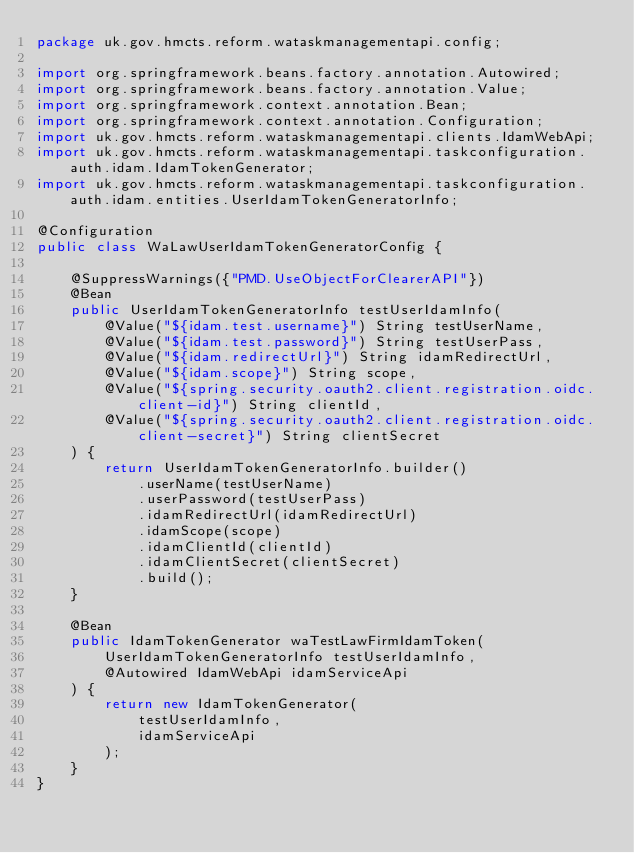Convert code to text. <code><loc_0><loc_0><loc_500><loc_500><_Java_>package uk.gov.hmcts.reform.wataskmanagementapi.config;

import org.springframework.beans.factory.annotation.Autowired;
import org.springframework.beans.factory.annotation.Value;
import org.springframework.context.annotation.Bean;
import org.springframework.context.annotation.Configuration;
import uk.gov.hmcts.reform.wataskmanagementapi.clients.IdamWebApi;
import uk.gov.hmcts.reform.wataskmanagementapi.taskconfiguration.auth.idam.IdamTokenGenerator;
import uk.gov.hmcts.reform.wataskmanagementapi.taskconfiguration.auth.idam.entities.UserIdamTokenGeneratorInfo;

@Configuration
public class WaLawUserIdamTokenGeneratorConfig {

    @SuppressWarnings({"PMD.UseObjectForClearerAPI"})
    @Bean
    public UserIdamTokenGeneratorInfo testUserIdamInfo(
        @Value("${idam.test.username}") String testUserName,
        @Value("${idam.test.password}") String testUserPass,
        @Value("${idam.redirectUrl}") String idamRedirectUrl,
        @Value("${idam.scope}") String scope,
        @Value("${spring.security.oauth2.client.registration.oidc.client-id}") String clientId,
        @Value("${spring.security.oauth2.client.registration.oidc.client-secret}") String clientSecret
    ) {
        return UserIdamTokenGeneratorInfo.builder()
            .userName(testUserName)
            .userPassword(testUserPass)
            .idamRedirectUrl(idamRedirectUrl)
            .idamScope(scope)
            .idamClientId(clientId)
            .idamClientSecret(clientSecret)
            .build();
    }

    @Bean
    public IdamTokenGenerator waTestLawFirmIdamToken(
        UserIdamTokenGeneratorInfo testUserIdamInfo,
        @Autowired IdamWebApi idamServiceApi
    ) {
        return new IdamTokenGenerator(
            testUserIdamInfo,
            idamServiceApi
        );
    }
}
</code> 